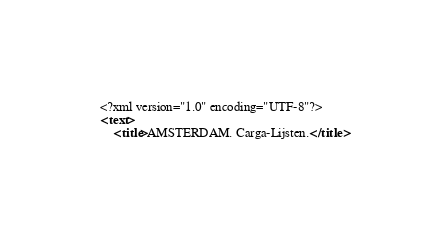<code> <loc_0><loc_0><loc_500><loc_500><_XML_><?xml version="1.0" encoding="UTF-8"?>
<text>
	<title>AMSTERDAM. Carga-Lijsten.</title></code> 